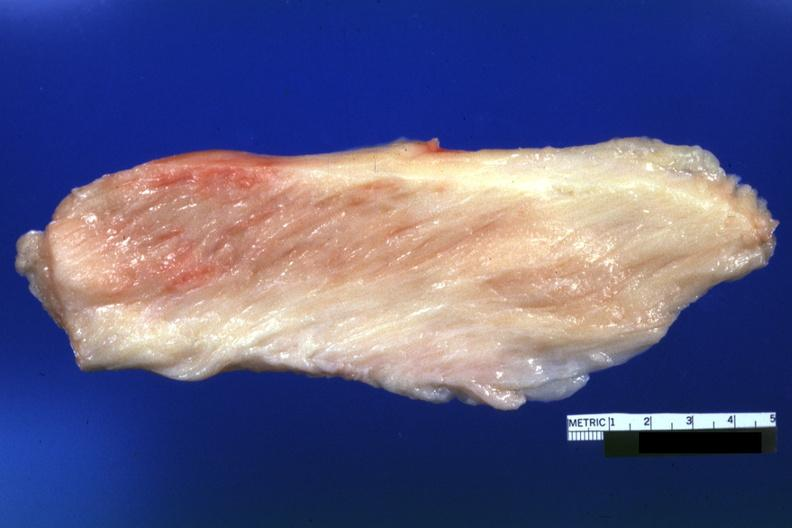what does this image show?
Answer the question using a single word or phrase. White muscle 